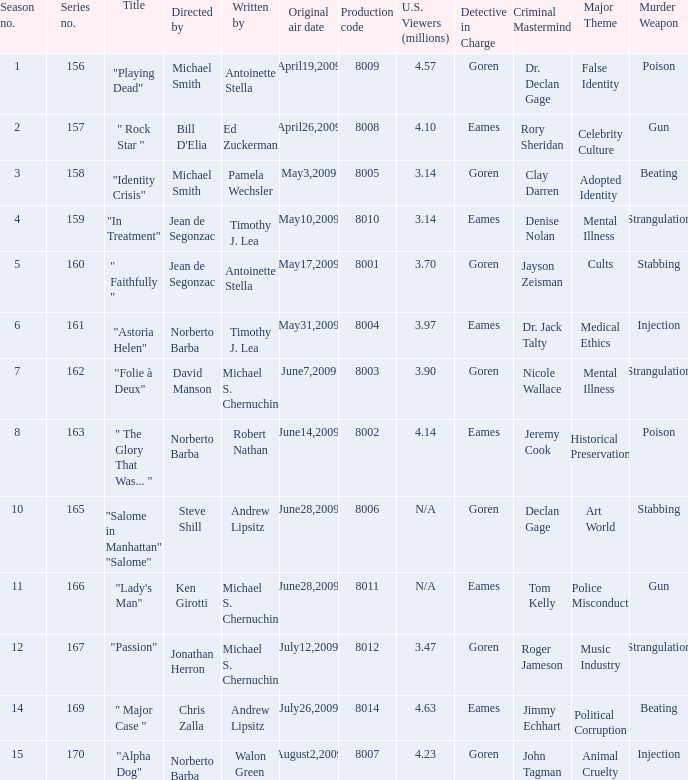Who are the writers when the production code is 8011? Michael S. Chernuchin. 